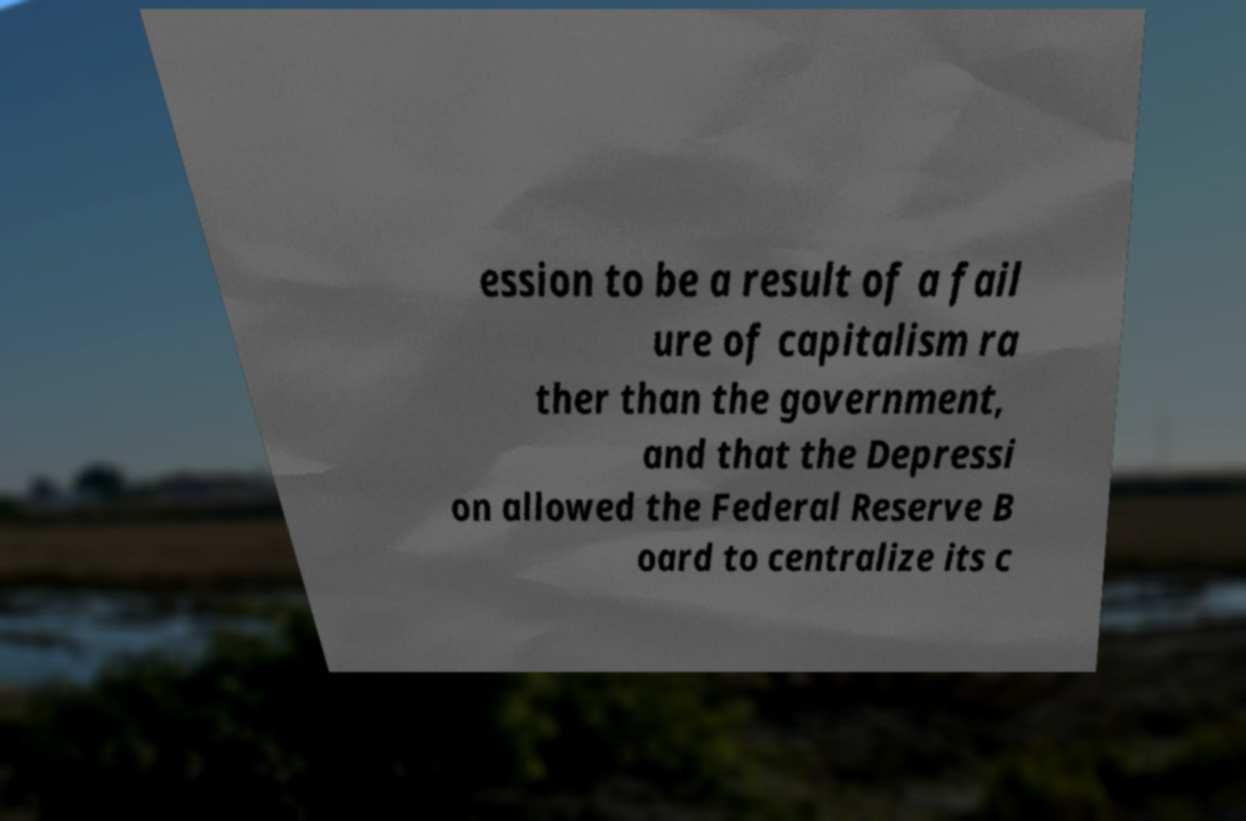I need the written content from this picture converted into text. Can you do that? ession to be a result of a fail ure of capitalism ra ther than the government, and that the Depressi on allowed the Federal Reserve B oard to centralize its c 